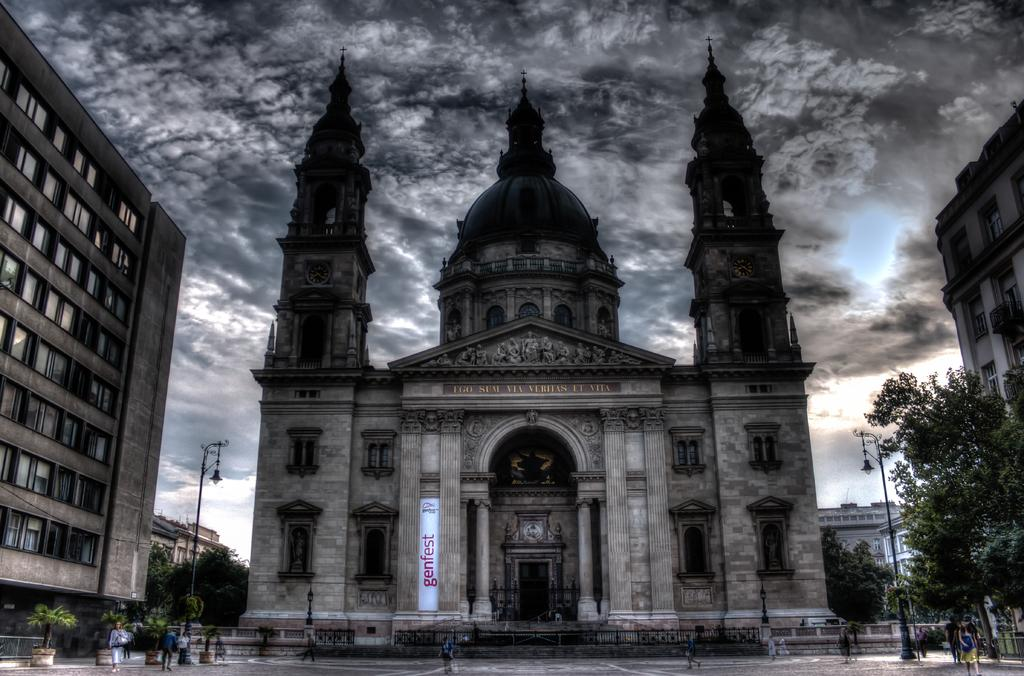What type of structure is the main subject of the image? There is a palace in the image. What can be seen on either side of the palace? Trees are present on either side of the palace. What other structures are visible in the image? There are buildings in the image. What is visible in the background of the image? The sky is visible in the image. What can be observed in the sky? Clouds are present in the sky. Is there any quicksand surrounding the palace in the image? There is no quicksand present in the image. What type of glass is used to construct the palace in the image? The image does not provide information about the materials used to construct the palace. 